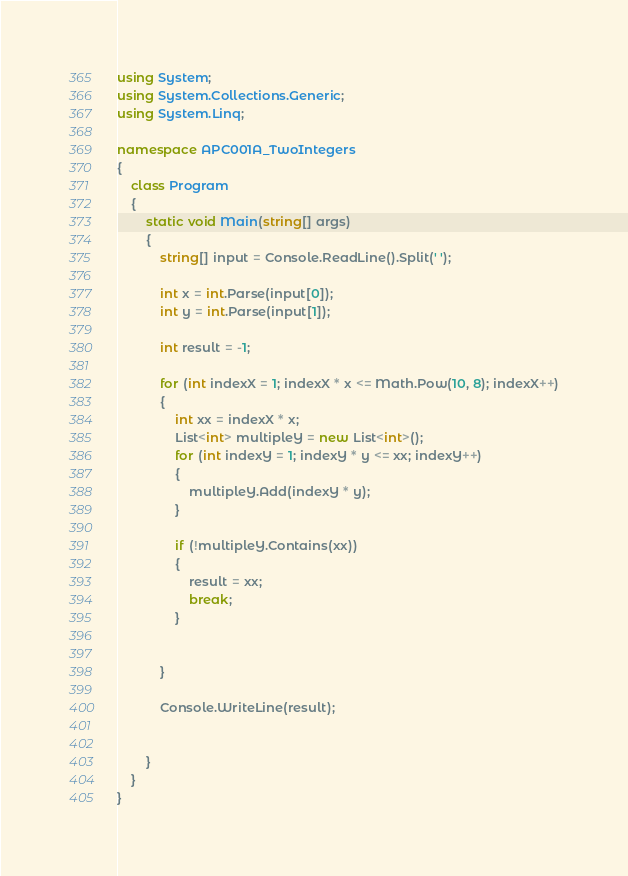Convert code to text. <code><loc_0><loc_0><loc_500><loc_500><_C#_>using System;
using System.Collections.Generic;
using System.Linq;

namespace APC001A_TwoIntegers
{
    class Program
    {
        static void Main(string[] args)
        {
            string[] input = Console.ReadLine().Split(' ');

            int x = int.Parse(input[0]);
            int y = int.Parse(input[1]);

            int result = -1;

            for (int indexX = 1; indexX * x <= Math.Pow(10, 8); indexX++)
            {
                int xx = indexX * x;
                List<int> multipleY = new List<int>();
                for (int indexY = 1; indexY * y <= xx; indexY++)
                {
                    multipleY.Add(indexY * y);
                }

                if (!multipleY.Contains(xx))
                {
                    result = xx;
                    break;
                }


            }

            Console.WriteLine(result);


        }
    }
}
</code> 